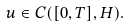Convert formula to latex. <formula><loc_0><loc_0><loc_500><loc_500>u \in C ( [ 0 , T ] , H ) .</formula> 